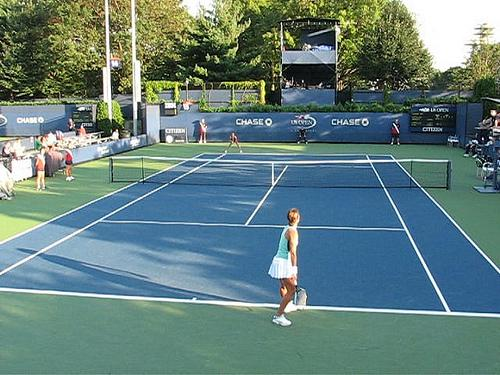Question: who is serving it?
Choices:
A. The man.
B. A robot.
C. A child.
D. The woman.
Answer with the letter. Answer: D Question: how many people are playing?
Choices:
A. Three.
B. Four.
C. Five.
D. Two.
Answer with the letter. Answer: D Question: when was the picture taken?
Choices:
A. In the afternoon.
B. Early morning.
C. Summertime.
D. At graduation.
Answer with the letter. Answer: A Question: where are they playing?
Choices:
A. Baseball diamond.
B. Hockey rink.
C. The beach.
D. A tennis court.
Answer with the letter. Answer: D Question: what color skirt is she wearing?
Choices:
A. White.
B. Yellow.
C. Blue.
D. Pink.
Answer with the letter. Answer: A 